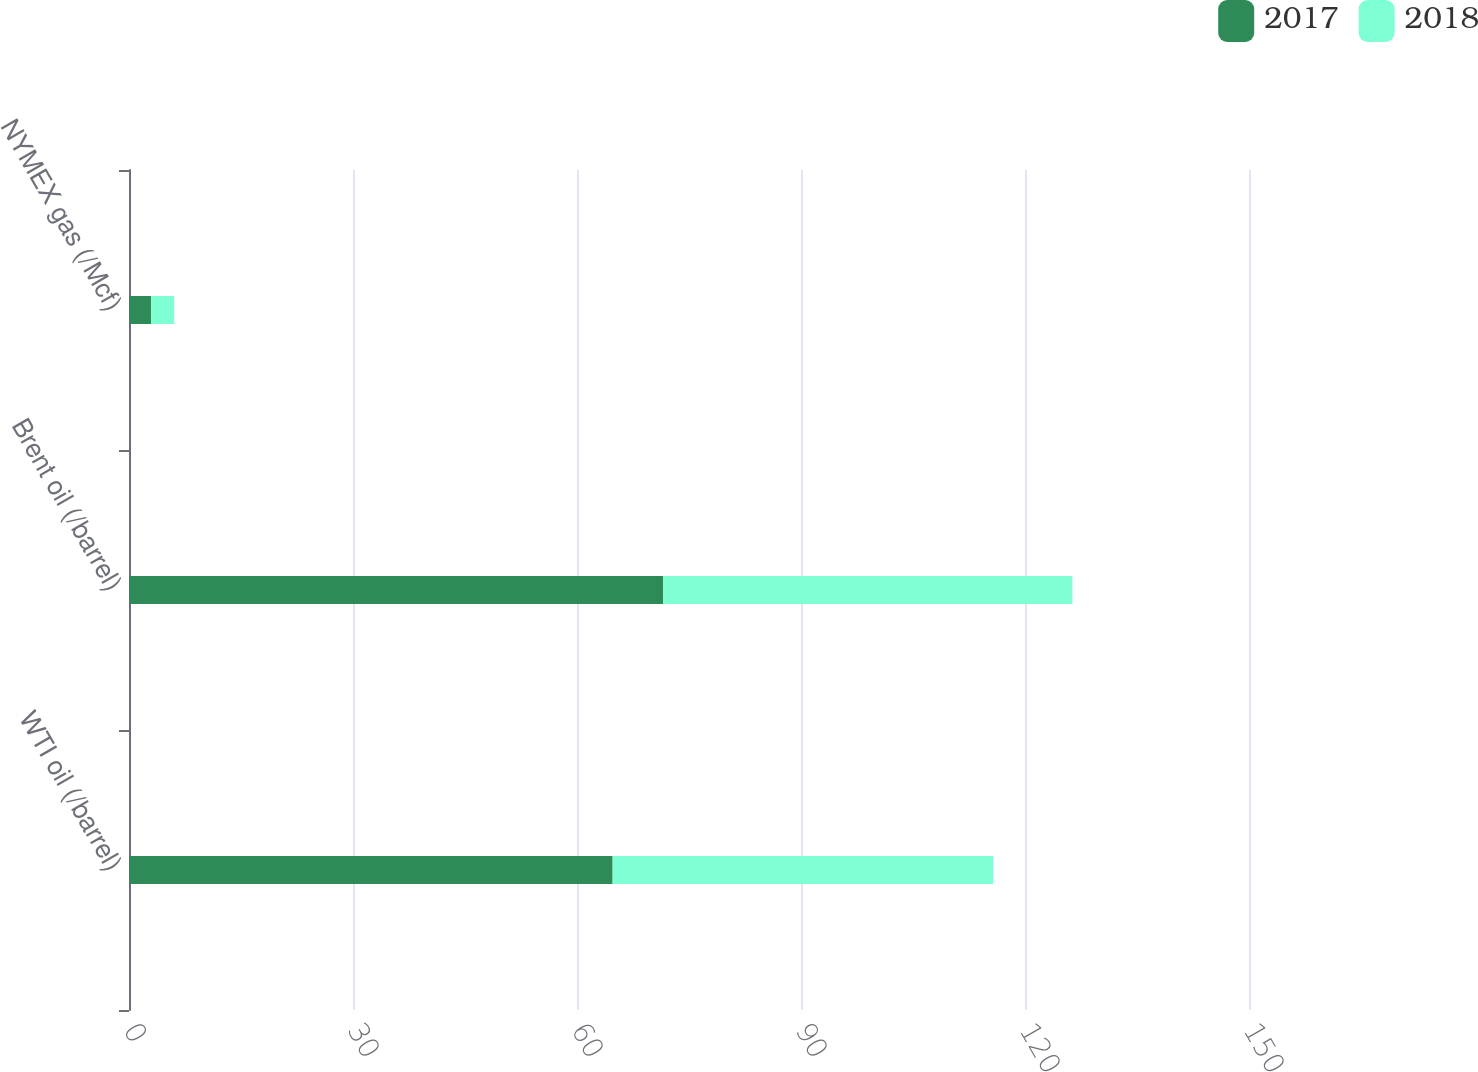Convert chart to OTSL. <chart><loc_0><loc_0><loc_500><loc_500><stacked_bar_chart><ecel><fcel>WTI oil (/barrel)<fcel>Brent oil (/barrel)<fcel>NYMEX gas (/Mcf)<nl><fcel>2017<fcel>64.77<fcel>71.53<fcel>2.97<nl><fcel>2018<fcel>50.95<fcel>54.82<fcel>3.09<nl></chart> 